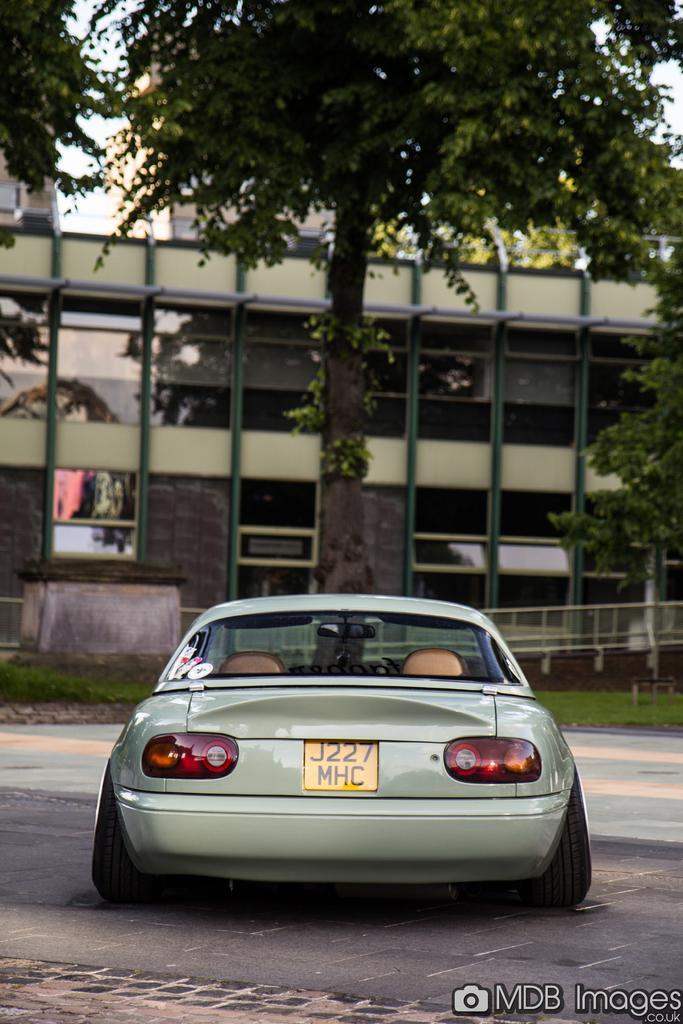Can you describe this image briefly? Vehicle is on the road. Background there are trees, building and grass. To this building there are glass windows. Bottom of the image there is a watermark. 